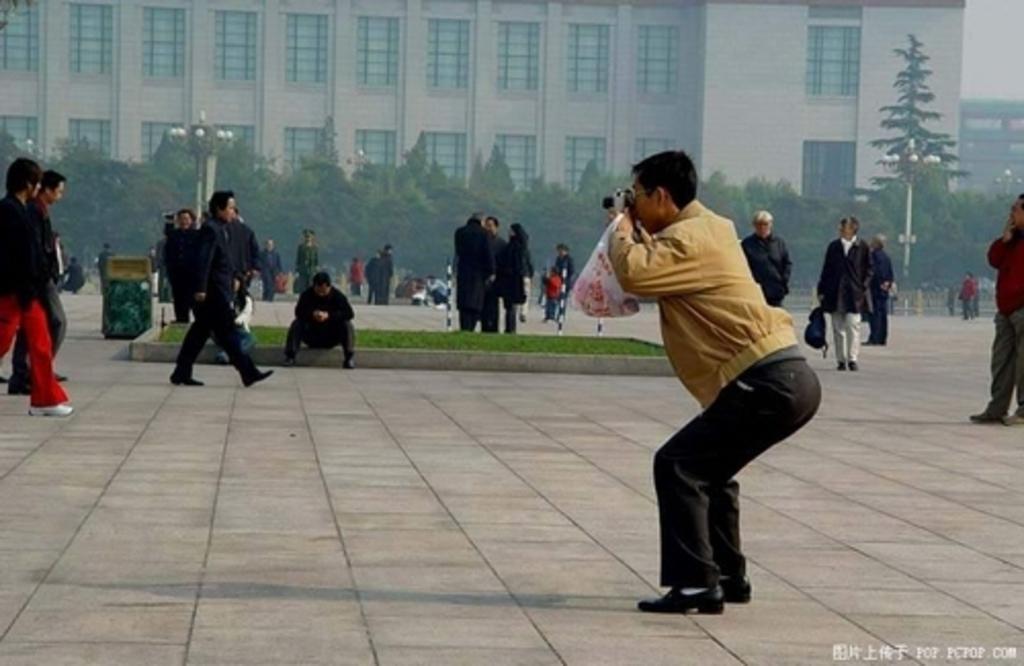Could you give a brief overview of what you see in this image? In this image, I can see groups of people standing, few people walking and there is a person sitting. There is grass, an object and lights to the poles. In the background, I can see the trees, buildings and the sky. In the bottom right corner of the image, there is a watermark. 